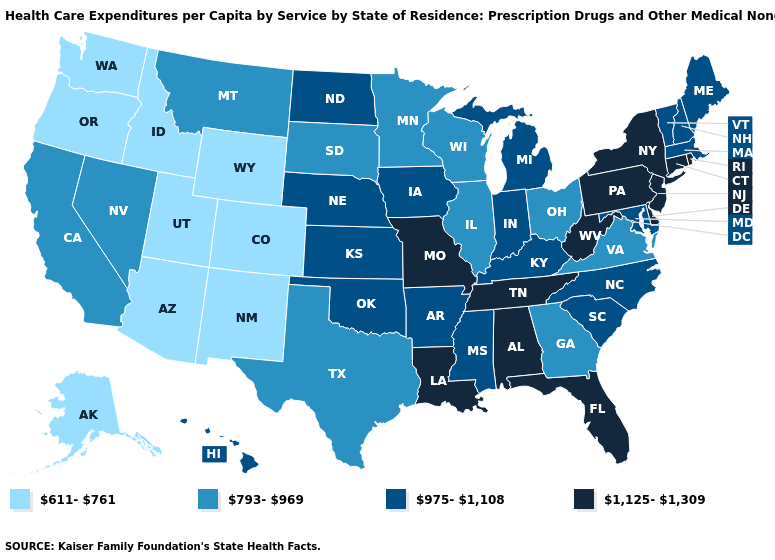What is the value of Tennessee?
Write a very short answer. 1,125-1,309. Which states have the lowest value in the USA?
Short answer required. Alaska, Arizona, Colorado, Idaho, New Mexico, Oregon, Utah, Washington, Wyoming. What is the lowest value in states that border Washington?
Concise answer only. 611-761. Name the states that have a value in the range 975-1,108?
Be succinct. Arkansas, Hawaii, Indiana, Iowa, Kansas, Kentucky, Maine, Maryland, Massachusetts, Michigan, Mississippi, Nebraska, New Hampshire, North Carolina, North Dakota, Oklahoma, South Carolina, Vermont. What is the value of South Dakota?
Be succinct. 793-969. Which states have the lowest value in the USA?
Be succinct. Alaska, Arizona, Colorado, Idaho, New Mexico, Oregon, Utah, Washington, Wyoming. Name the states that have a value in the range 611-761?
Give a very brief answer. Alaska, Arizona, Colorado, Idaho, New Mexico, Oregon, Utah, Washington, Wyoming. Does New Jersey have the lowest value in the Northeast?
Short answer required. No. Among the states that border Arizona , does Utah have the lowest value?
Give a very brief answer. Yes. What is the highest value in states that border Washington?
Quick response, please. 611-761. What is the lowest value in states that border Montana?
Be succinct. 611-761. What is the value of California?
Write a very short answer. 793-969. What is the value of Delaware?
Concise answer only. 1,125-1,309. What is the value of Ohio?
Concise answer only. 793-969. Among the states that border Kentucky , does Ohio have the lowest value?
Quick response, please. Yes. 